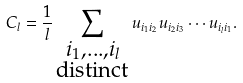<formula> <loc_0><loc_0><loc_500><loc_500>C _ { l } = \frac { 1 } { l } \sum _ { \substack { i _ { 1 } , \dots , i _ { l } \\ \text {distinct} } } u _ { i _ { 1 } i _ { 2 } } u _ { i _ { 2 } i _ { 3 } } \cdots u _ { i _ { l } i _ { 1 } } .</formula> 